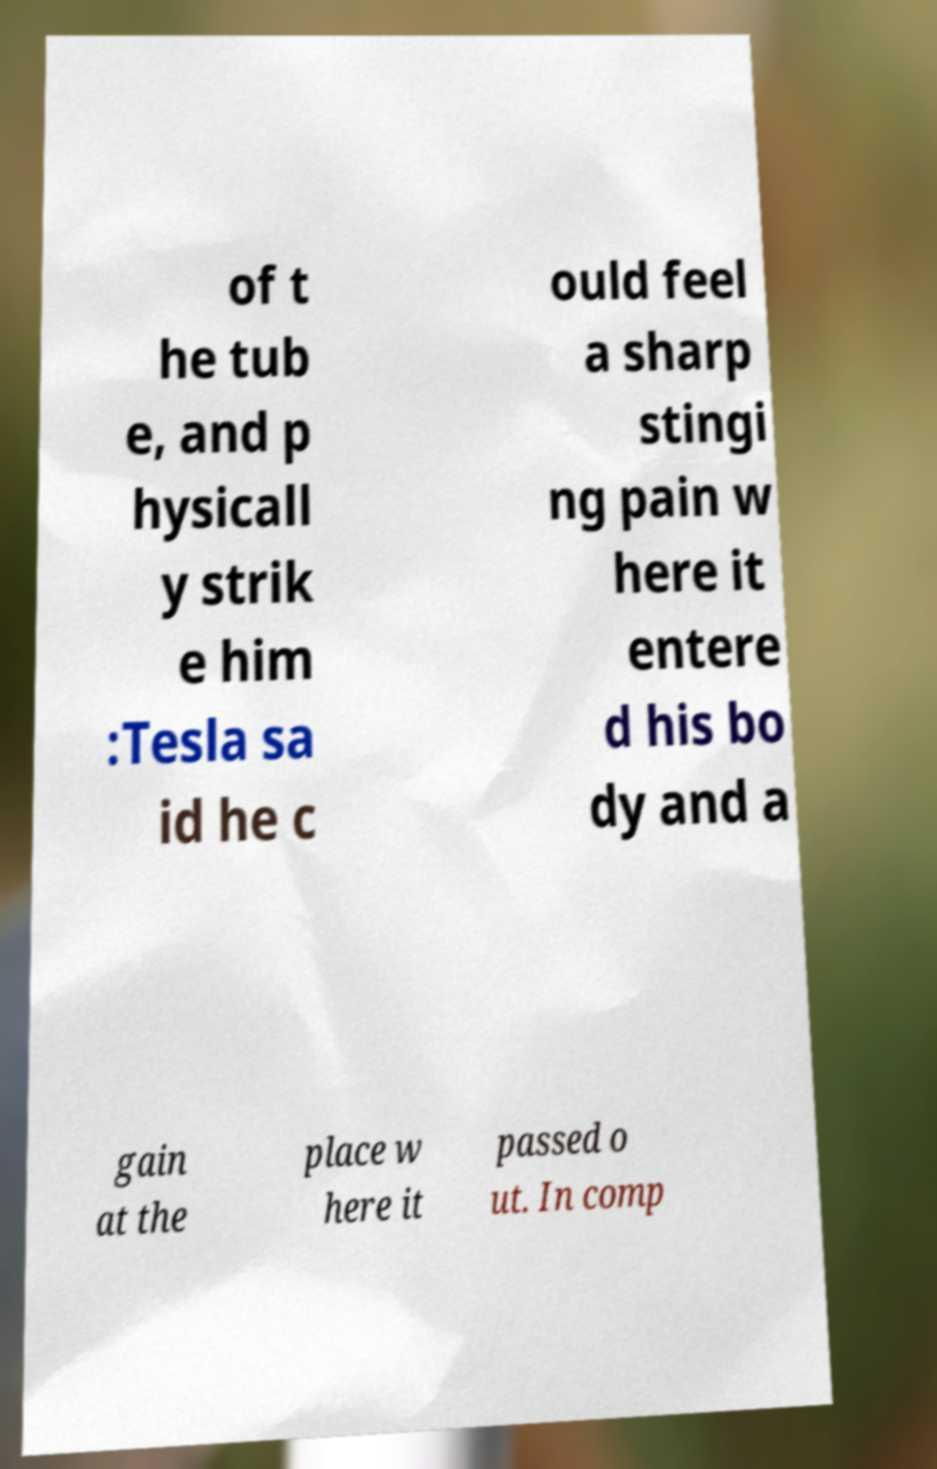I need the written content from this picture converted into text. Can you do that? of t he tub e, and p hysicall y strik e him :Tesla sa id he c ould feel a sharp stingi ng pain w here it entere d his bo dy and a gain at the place w here it passed o ut. In comp 